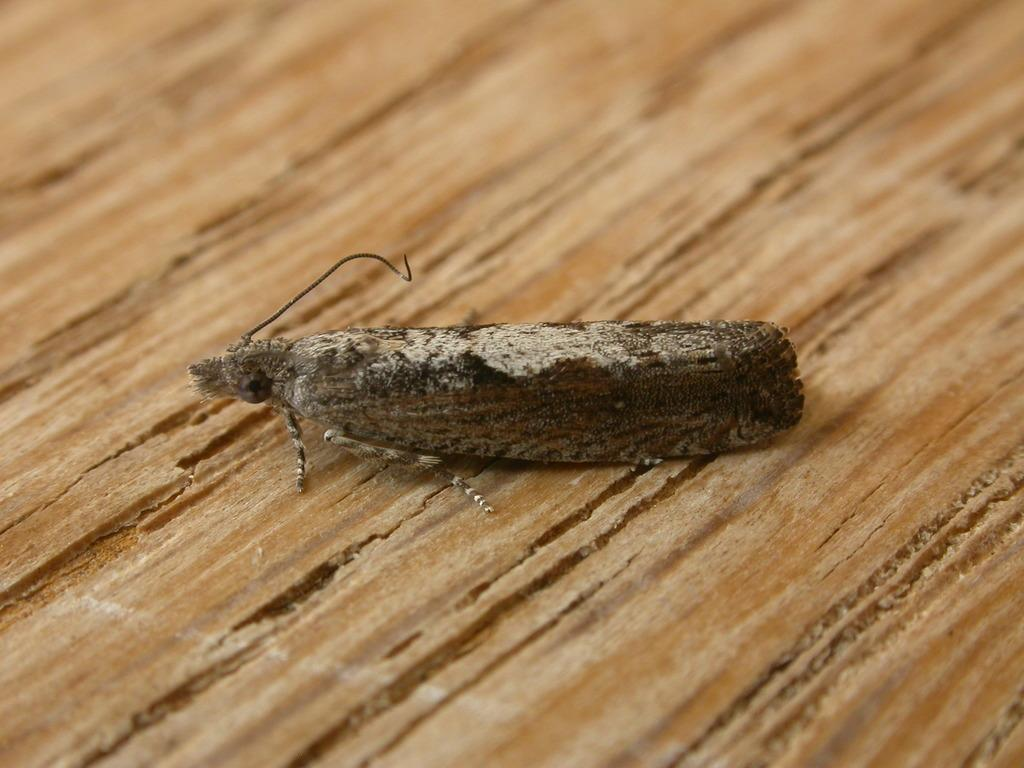Where was the image taken? The image was taken outdoors. What can be seen at the bottom of the image? There is a wooden platform at the bottom of the image. Are there any living creatures visible in the image? Yes, there is a fly on the wooden platform. What type of ring can be seen on the fly's leg in the image? There is no ring visible on the fly's leg in the image. What flavor of berry is the fly sitting on in the image? There is no berry present in the image, and therefore no flavor can be determined. 